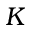Convert formula to latex. <formula><loc_0><loc_0><loc_500><loc_500>K</formula> 